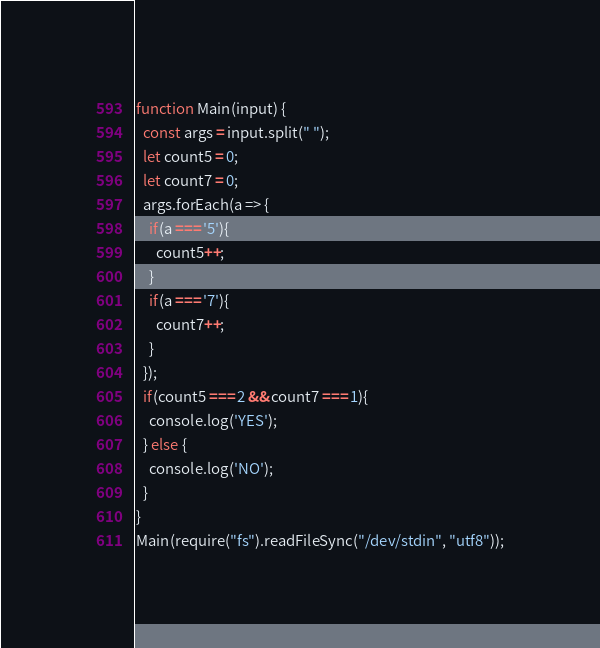Convert code to text. <code><loc_0><loc_0><loc_500><loc_500><_JavaScript_>function Main(input) {
  const args = input.split(" ");
  let count5 = 0;
  let count7 = 0;
  args.forEach(a => {
    if(a === '5'){
      count5++;
    }
    if(a === '7'){
      count7++;
    }
  });
  if(count5 === 2 && count7 === 1){
    console.log('YES');
  } else {
    console.log('NO');
  }
}
Main(require("fs").readFileSync("/dev/stdin", "utf8"));</code> 